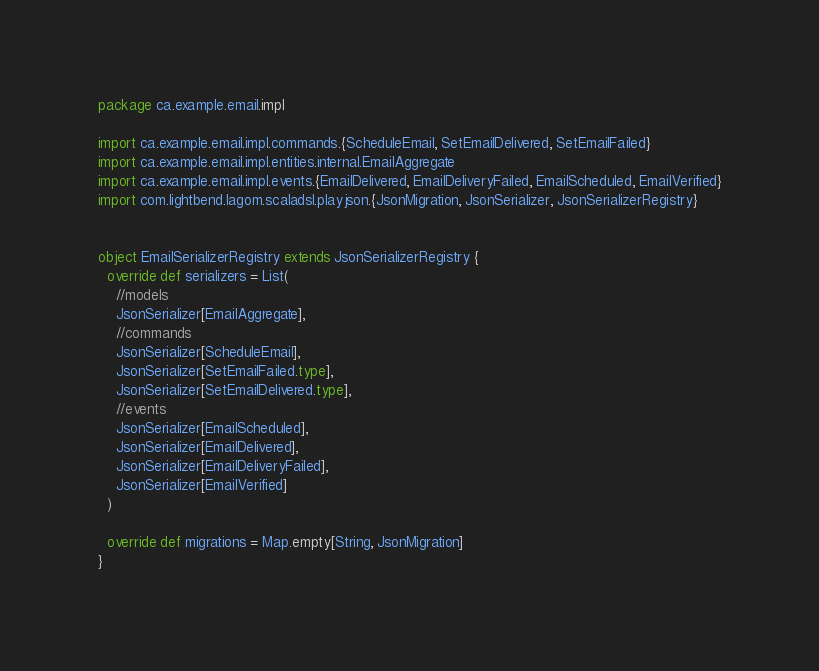<code> <loc_0><loc_0><loc_500><loc_500><_Scala_>package ca.example.email.impl

import ca.example.email.impl.commands.{ScheduleEmail, SetEmailDelivered, SetEmailFailed}
import ca.example.email.impl.entities.internal.EmailAggregate
import ca.example.email.impl.events.{EmailDelivered, EmailDeliveryFailed, EmailScheduled, EmailVerified}
import com.lightbend.lagom.scaladsl.playjson.{JsonMigration, JsonSerializer, JsonSerializerRegistry}


object EmailSerializerRegistry extends JsonSerializerRegistry {
  override def serializers = List(
    //models
    JsonSerializer[EmailAggregate],
    //commands
    JsonSerializer[ScheduleEmail],
    JsonSerializer[SetEmailFailed.type],
    JsonSerializer[SetEmailDelivered.type],
    //events
    JsonSerializer[EmailScheduled],
    JsonSerializer[EmailDelivered],
    JsonSerializer[EmailDeliveryFailed],
    JsonSerializer[EmailVerified]
  )

  override def migrations = Map.empty[String, JsonMigration]
}

</code> 